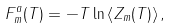Convert formula to latex. <formula><loc_0><loc_0><loc_500><loc_500>F _ { m } ^ { a } ( T ) = - T \ln \left \langle Z _ { m } ( T ) \right \rangle ,</formula> 